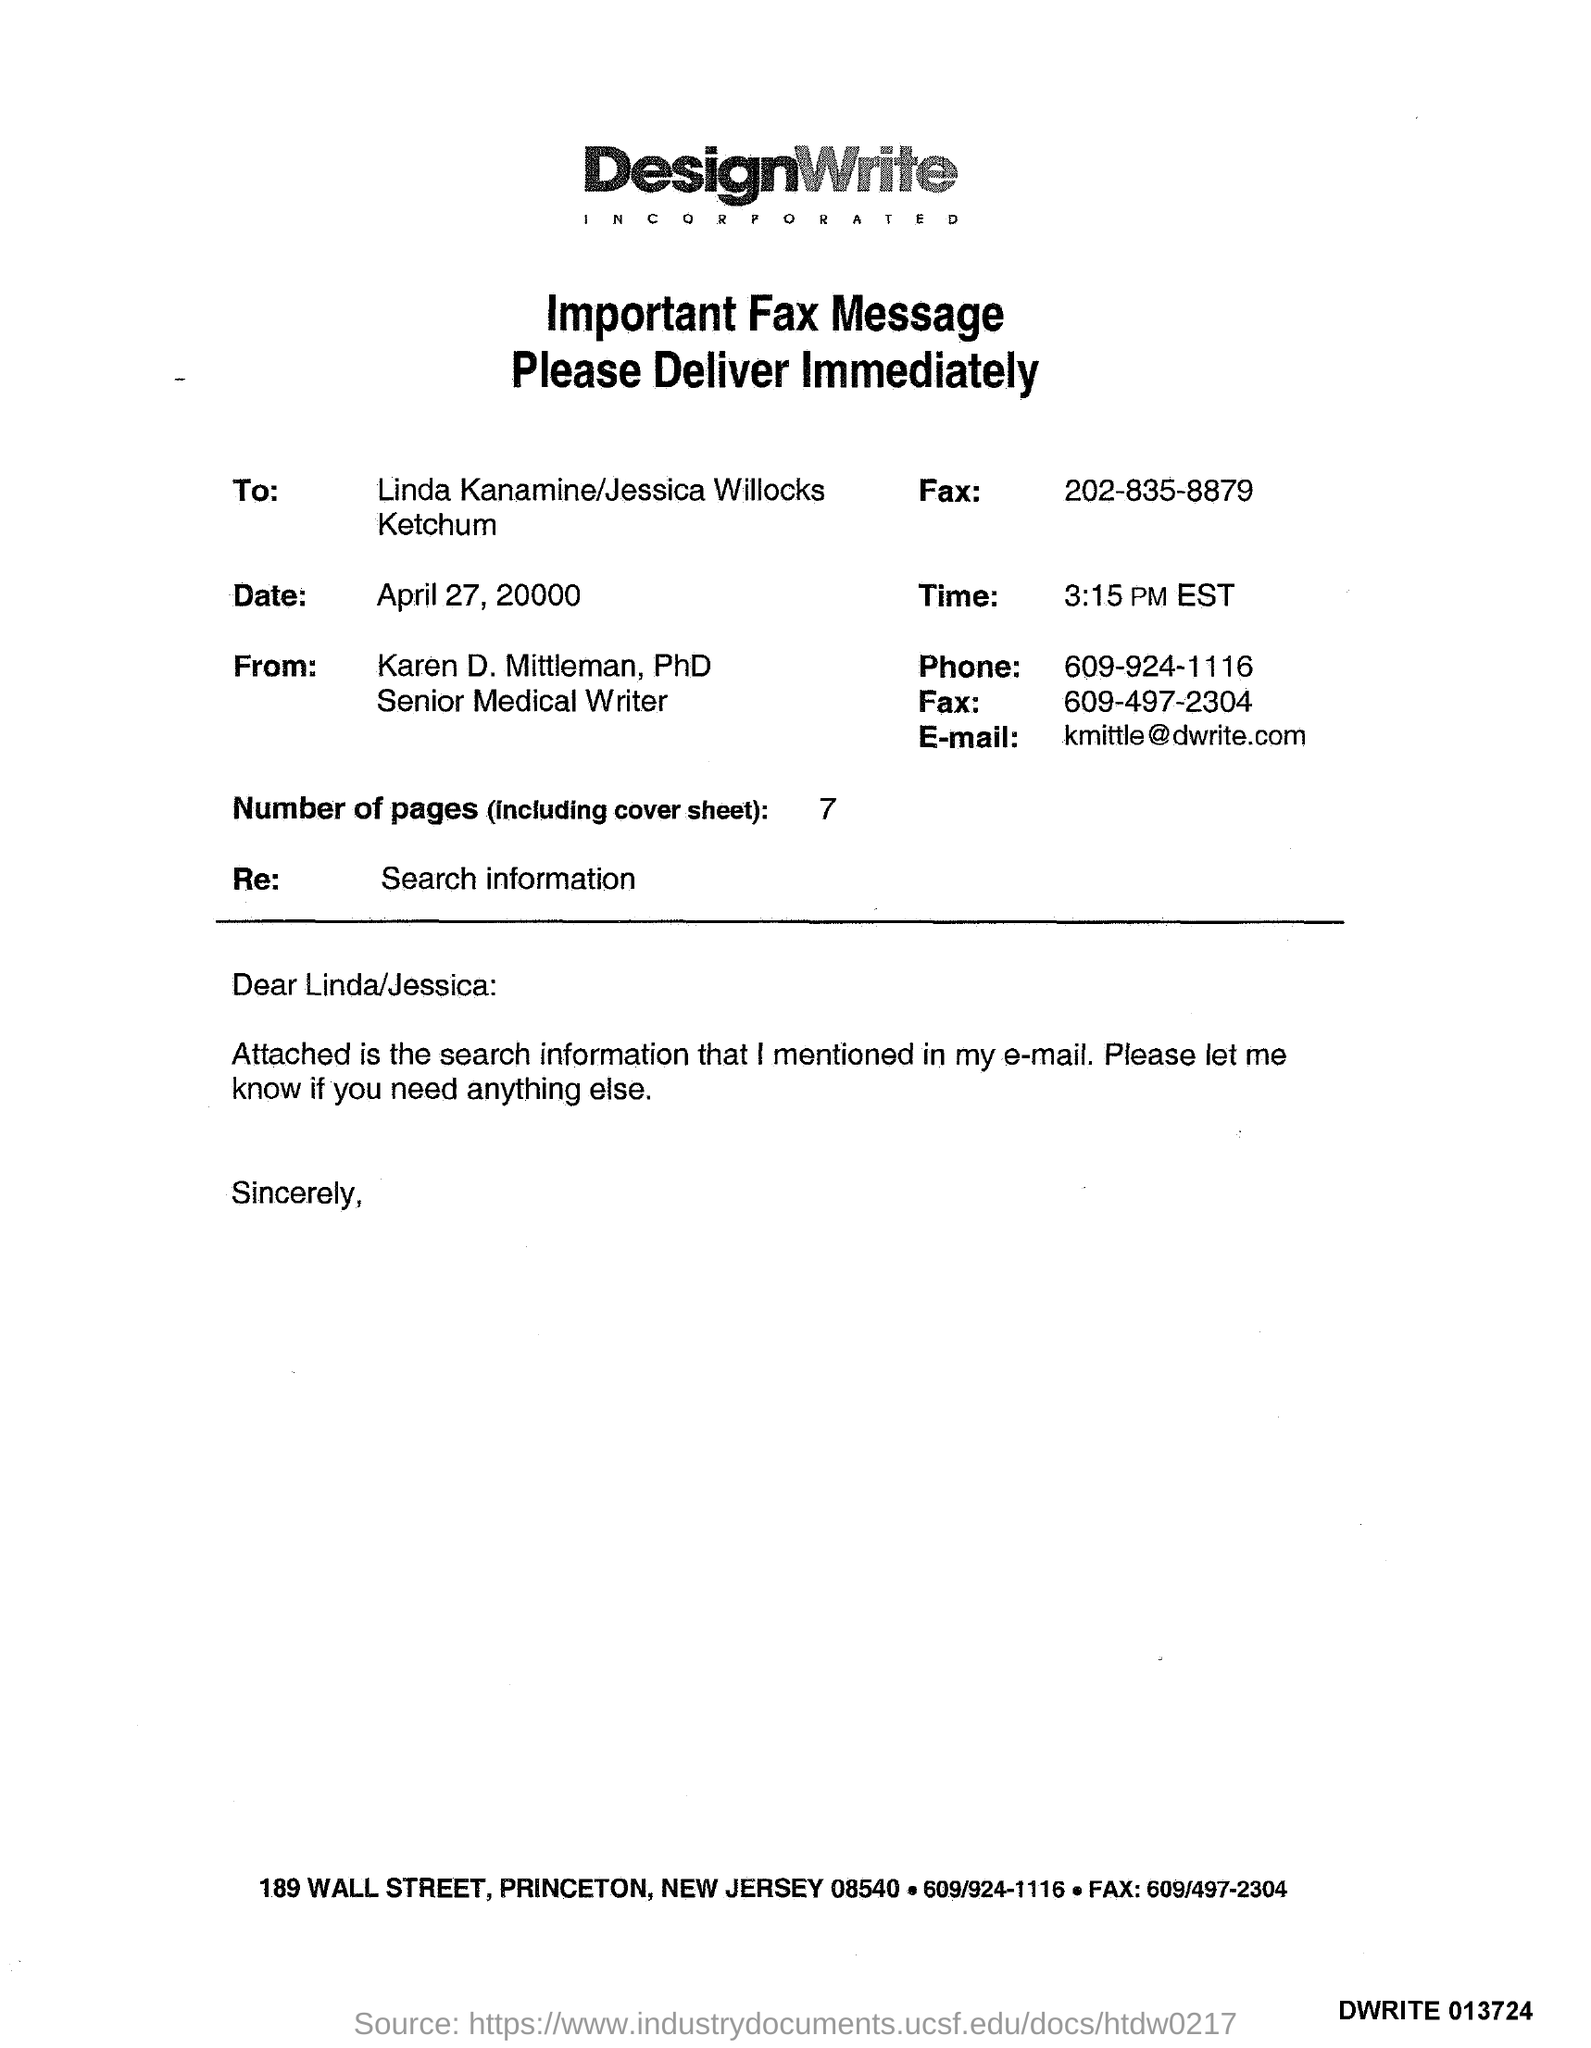Specify some key components in this picture. The sender's phone number is 609-924-1116. The memorandum is addressed to Linda Kanamine and Jessica Willocks Ketchum. The sender's fax number is 609-497-2304. There are 7 pages in this sheet. The date mentioned in the document is April 27, 20000. 